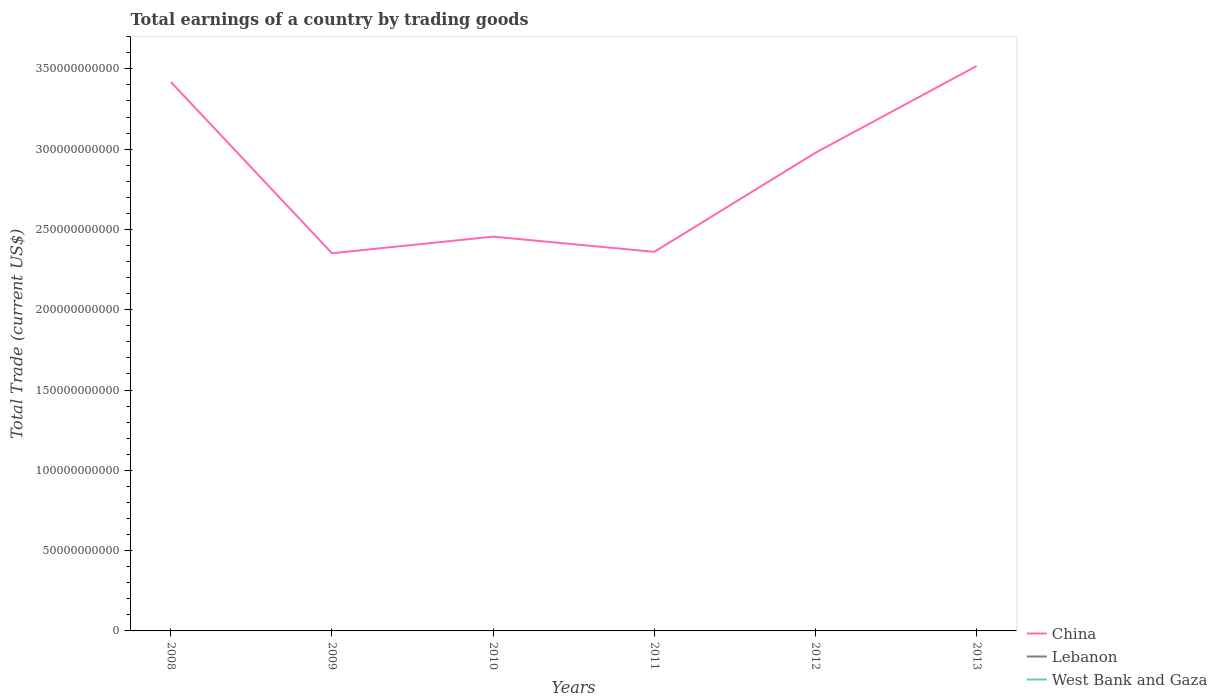How many different coloured lines are there?
Give a very brief answer. 1. What is the total total earnings in China in the graph?
Provide a succinct answer. 9.63e+1. What is the difference between the highest and the lowest total earnings in Lebanon?
Provide a short and direct response. 0. How many lines are there?
Provide a succinct answer. 1. How many years are there in the graph?
Offer a very short reply. 6. Does the graph contain any zero values?
Your answer should be compact. Yes. Does the graph contain grids?
Provide a succinct answer. No. What is the title of the graph?
Your answer should be compact. Total earnings of a country by trading goods. What is the label or title of the Y-axis?
Provide a succinct answer. Total Trade (current US$). What is the Total Trade (current US$) of China in 2008?
Offer a terse response. 3.42e+11. What is the Total Trade (current US$) in Lebanon in 2008?
Your answer should be compact. 0. What is the Total Trade (current US$) in West Bank and Gaza in 2008?
Keep it short and to the point. 0. What is the Total Trade (current US$) in China in 2009?
Provide a short and direct response. 2.35e+11. What is the Total Trade (current US$) of Lebanon in 2009?
Provide a succinct answer. 0. What is the Total Trade (current US$) in West Bank and Gaza in 2009?
Provide a succinct answer. 0. What is the Total Trade (current US$) of China in 2010?
Provide a short and direct response. 2.46e+11. What is the Total Trade (current US$) of West Bank and Gaza in 2010?
Give a very brief answer. 0. What is the Total Trade (current US$) in China in 2011?
Make the answer very short. 2.36e+11. What is the Total Trade (current US$) in Lebanon in 2011?
Provide a short and direct response. 0. What is the Total Trade (current US$) of China in 2012?
Offer a terse response. 2.98e+11. What is the Total Trade (current US$) of China in 2013?
Ensure brevity in your answer.  3.52e+11. What is the Total Trade (current US$) in West Bank and Gaza in 2013?
Ensure brevity in your answer.  0. Across all years, what is the maximum Total Trade (current US$) of China?
Your answer should be compact. 3.52e+11. Across all years, what is the minimum Total Trade (current US$) of China?
Ensure brevity in your answer.  2.35e+11. What is the total Total Trade (current US$) in China in the graph?
Your answer should be very brief. 1.71e+12. What is the total Total Trade (current US$) in West Bank and Gaza in the graph?
Offer a very short reply. 0. What is the difference between the Total Trade (current US$) of China in 2008 and that in 2009?
Your answer should be compact. 1.07e+11. What is the difference between the Total Trade (current US$) of China in 2008 and that in 2010?
Offer a terse response. 9.63e+1. What is the difference between the Total Trade (current US$) in China in 2008 and that in 2011?
Your answer should be compact. 1.06e+11. What is the difference between the Total Trade (current US$) of China in 2008 and that in 2012?
Your answer should be very brief. 4.41e+1. What is the difference between the Total Trade (current US$) of China in 2008 and that in 2013?
Your answer should be very brief. -9.91e+09. What is the difference between the Total Trade (current US$) of China in 2009 and that in 2010?
Your response must be concise. -1.04e+1. What is the difference between the Total Trade (current US$) in China in 2009 and that in 2011?
Offer a very short reply. -8.71e+08. What is the difference between the Total Trade (current US$) in China in 2009 and that in 2012?
Offer a very short reply. -6.26e+1. What is the difference between the Total Trade (current US$) of China in 2009 and that in 2013?
Your answer should be very brief. -1.17e+11. What is the difference between the Total Trade (current US$) in China in 2010 and that in 2011?
Your response must be concise. 9.49e+09. What is the difference between the Total Trade (current US$) of China in 2010 and that in 2012?
Ensure brevity in your answer.  -5.22e+1. What is the difference between the Total Trade (current US$) of China in 2010 and that in 2013?
Provide a succinct answer. -1.06e+11. What is the difference between the Total Trade (current US$) of China in 2011 and that in 2012?
Offer a terse response. -6.17e+1. What is the difference between the Total Trade (current US$) of China in 2011 and that in 2013?
Provide a short and direct response. -1.16e+11. What is the difference between the Total Trade (current US$) of China in 2012 and that in 2013?
Offer a very short reply. -5.40e+1. What is the average Total Trade (current US$) of China per year?
Offer a terse response. 2.85e+11. What is the average Total Trade (current US$) of Lebanon per year?
Your response must be concise. 0. What is the average Total Trade (current US$) in West Bank and Gaza per year?
Your answer should be compact. 0. What is the ratio of the Total Trade (current US$) in China in 2008 to that in 2009?
Offer a very short reply. 1.45. What is the ratio of the Total Trade (current US$) in China in 2008 to that in 2010?
Give a very brief answer. 1.39. What is the ratio of the Total Trade (current US$) of China in 2008 to that in 2011?
Provide a short and direct response. 1.45. What is the ratio of the Total Trade (current US$) of China in 2008 to that in 2012?
Your answer should be compact. 1.15. What is the ratio of the Total Trade (current US$) in China in 2008 to that in 2013?
Ensure brevity in your answer.  0.97. What is the ratio of the Total Trade (current US$) in China in 2009 to that in 2010?
Keep it short and to the point. 0.96. What is the ratio of the Total Trade (current US$) in China in 2009 to that in 2012?
Ensure brevity in your answer.  0.79. What is the ratio of the Total Trade (current US$) of China in 2009 to that in 2013?
Offer a very short reply. 0.67. What is the ratio of the Total Trade (current US$) in China in 2010 to that in 2011?
Provide a short and direct response. 1.04. What is the ratio of the Total Trade (current US$) in China in 2010 to that in 2012?
Keep it short and to the point. 0.82. What is the ratio of the Total Trade (current US$) in China in 2010 to that in 2013?
Make the answer very short. 0.7. What is the ratio of the Total Trade (current US$) in China in 2011 to that in 2012?
Your answer should be very brief. 0.79. What is the ratio of the Total Trade (current US$) in China in 2011 to that in 2013?
Ensure brevity in your answer.  0.67. What is the ratio of the Total Trade (current US$) in China in 2012 to that in 2013?
Keep it short and to the point. 0.85. What is the difference between the highest and the second highest Total Trade (current US$) in China?
Offer a very short reply. 9.91e+09. What is the difference between the highest and the lowest Total Trade (current US$) of China?
Provide a short and direct response. 1.17e+11. 